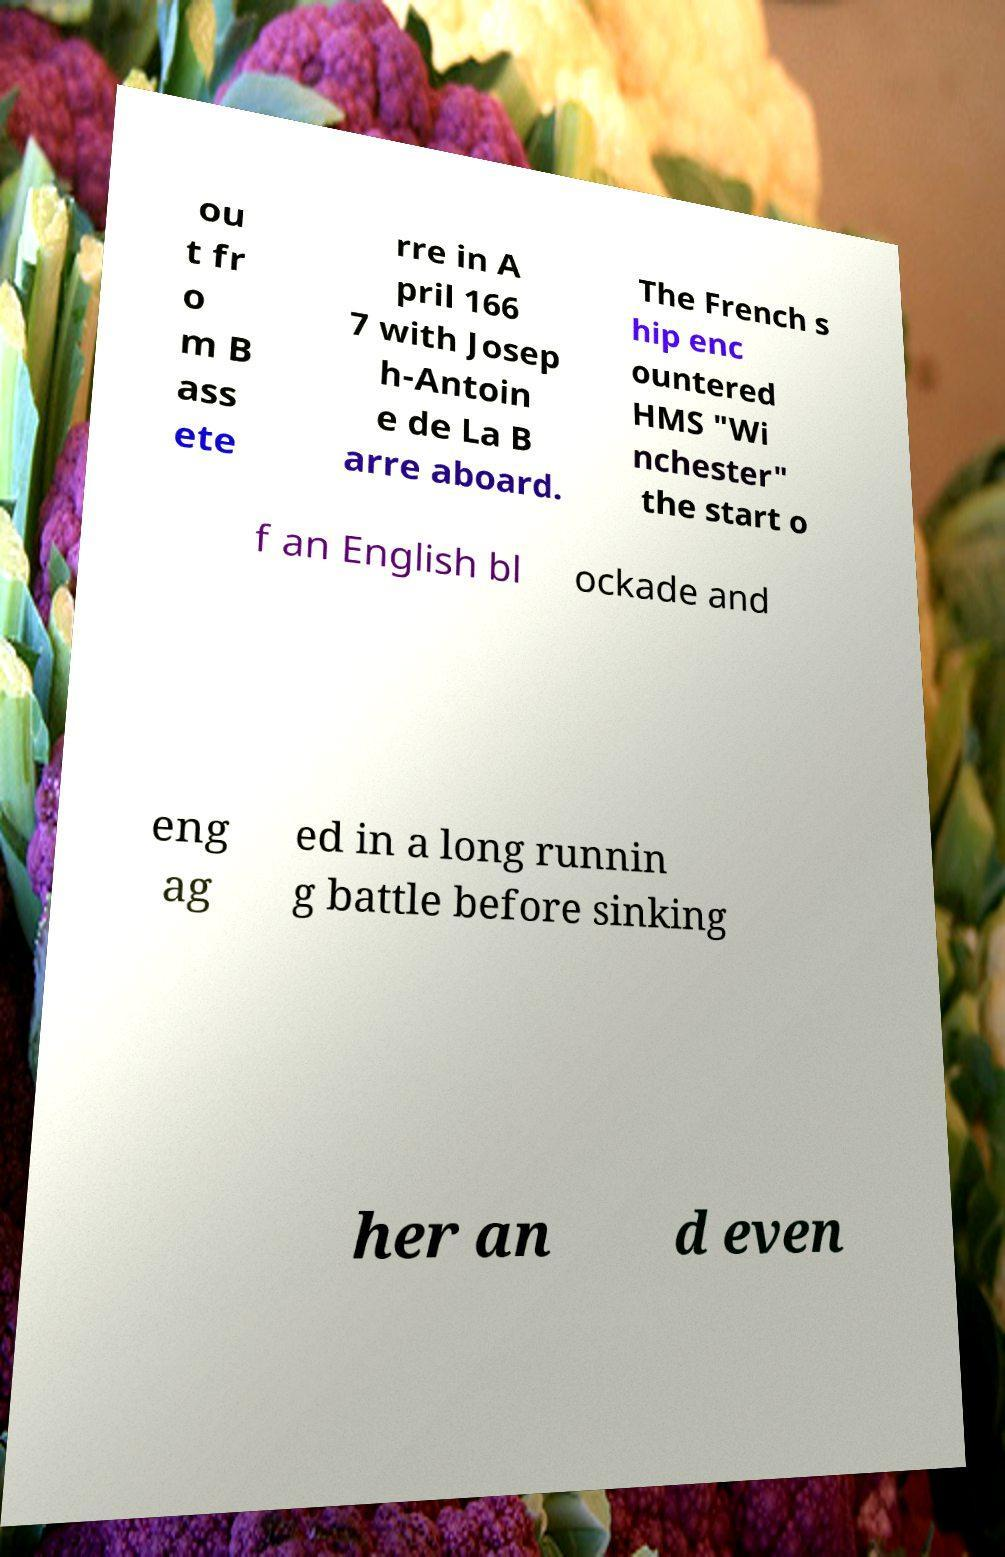Can you read and provide the text displayed in the image?This photo seems to have some interesting text. Can you extract and type it out for me? ou t fr o m B ass ete rre in A pril 166 7 with Josep h-Antoin e de La B arre aboard. The French s hip enc ountered HMS "Wi nchester" the start o f an English bl ockade and eng ag ed in a long runnin g battle before sinking her an d even 